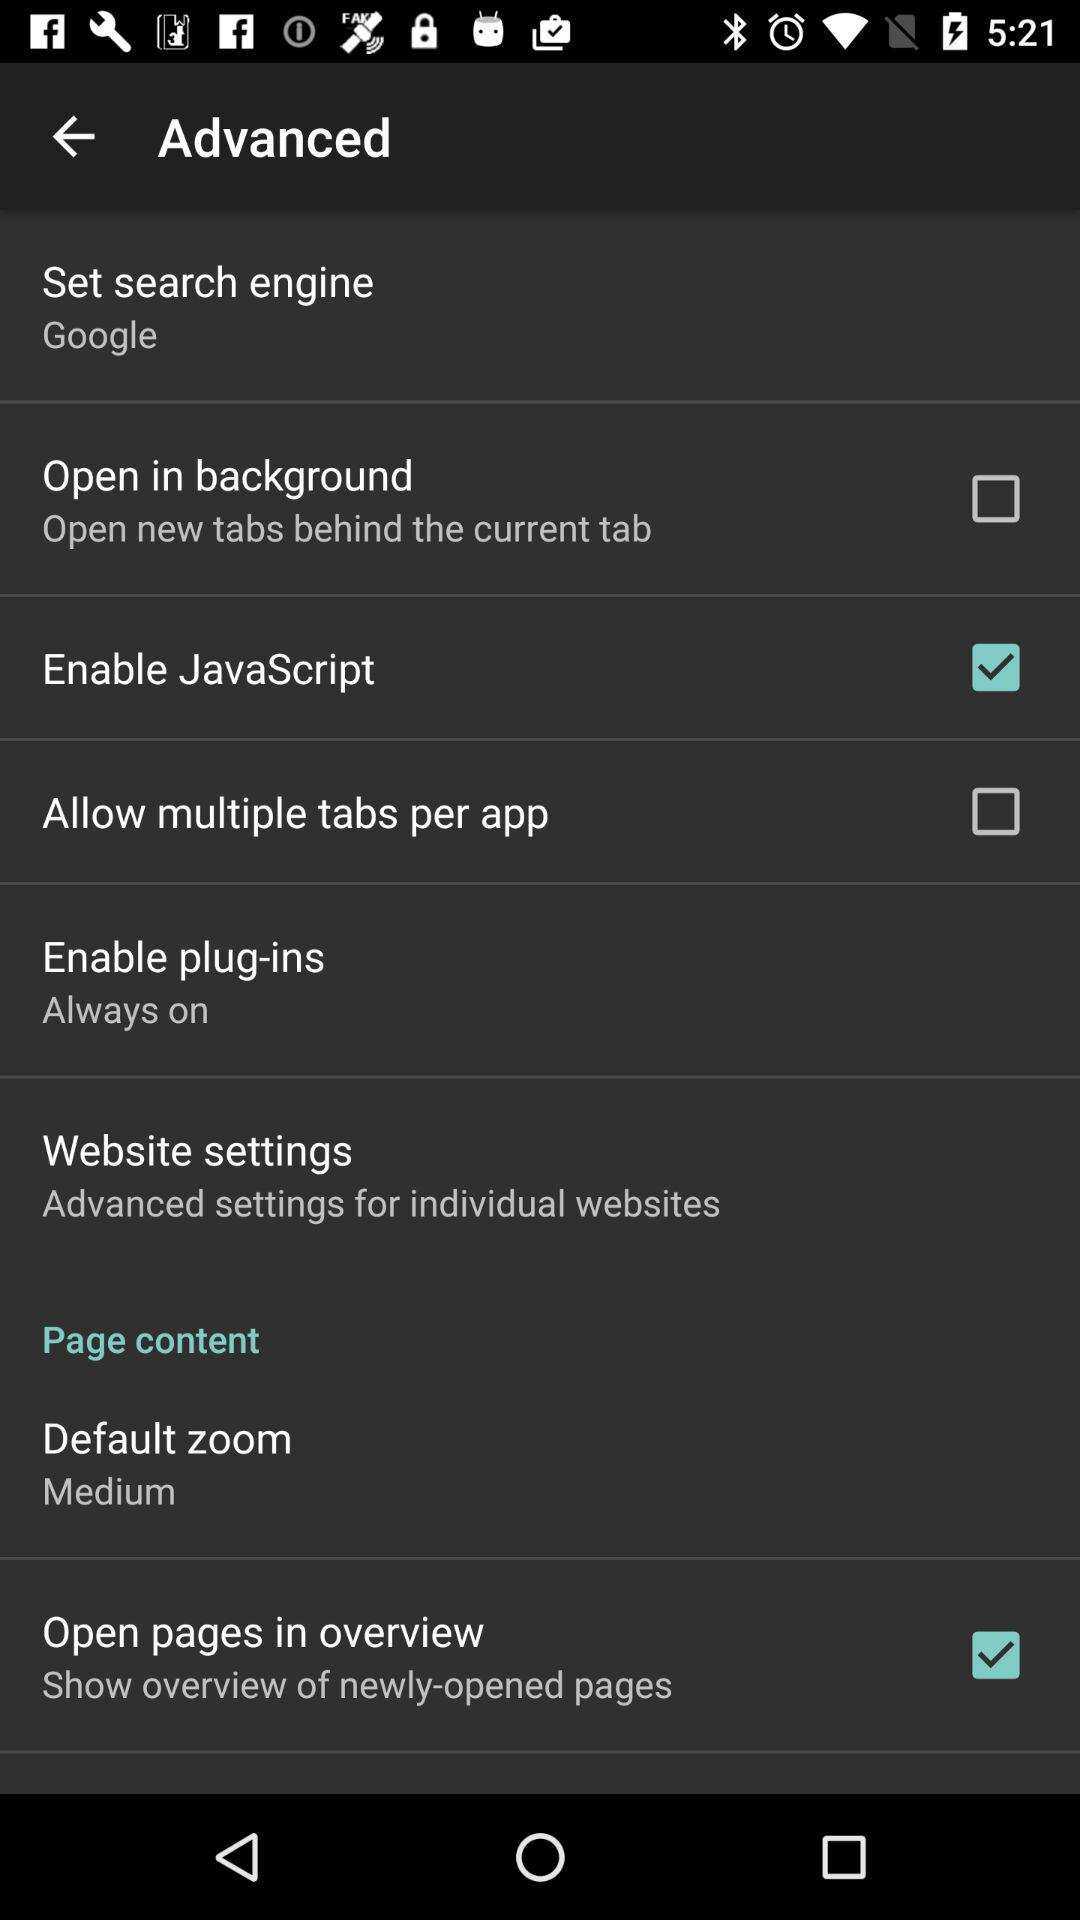What is the set search engine? The set search engine is "Google". 